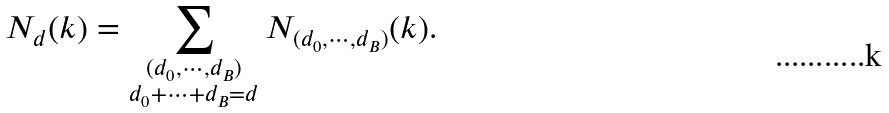<formula> <loc_0><loc_0><loc_500><loc_500>N _ { d } ( k ) = \sum _ { \substack { ( d _ { 0 } , \cdots , d _ { B } ) \\ d _ { 0 } + \cdots + d _ { B } = d } } N _ { ( d _ { 0 } , \cdots , d _ { B } ) } ( k ) .</formula> 